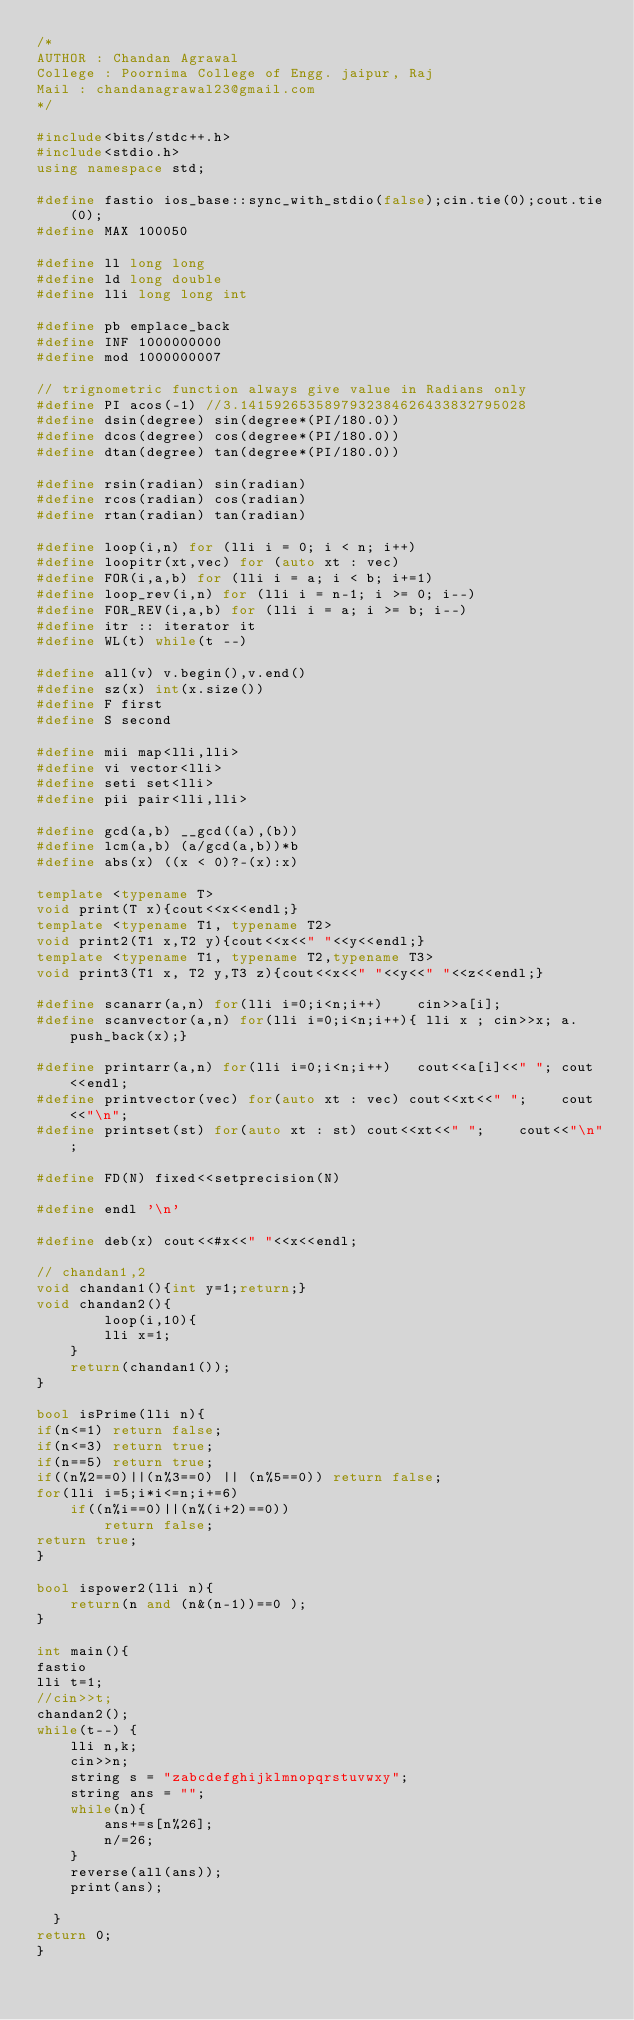Convert code to text. <code><loc_0><loc_0><loc_500><loc_500><_C++_>/*
AUTHOR : Chandan Agrawal
College : Poornima College of Engg. jaipur, Raj
Mail : chandanagrawal23@gmail.com
*/

#include<bits/stdc++.h>
#include<stdio.h>
using namespace std;

#define fastio ios_base::sync_with_stdio(false);cin.tie(0);cout.tie(0);
#define MAX 100050

#define ll long long
#define ld long double
#define lli long long int

#define pb emplace_back
#define INF 1000000000
#define mod 1000000007

// trignometric function always give value in Radians only
#define PI acos(-1) //3.1415926535897932384626433832795028
#define dsin(degree) sin(degree*(PI/180.0))
#define dcos(degree) cos(degree*(PI/180.0))
#define dtan(degree) tan(degree*(PI/180.0))

#define rsin(radian) sin(radian)
#define rcos(radian) cos(radian)
#define rtan(radian) tan(radian)

#define loop(i,n) for (lli i = 0; i < n; i++)
#define loopitr(xt,vec) for (auto xt : vec)
#define FOR(i,a,b) for (lli i = a; i < b; i+=1)
#define loop_rev(i,n) for (lli i = n-1; i >= 0; i--)
#define FOR_REV(i,a,b) for (lli i = a; i >= b; i--)
#define itr :: iterator it
#define WL(t) while(t --)

#define all(v) v.begin(),v.end()
#define sz(x) int(x.size())
#define F first
#define S second

#define mii map<lli,lli>
#define vi vector<lli>
#define seti set<lli>
#define pii pair<lli,lli>

#define gcd(a,b) __gcd((a),(b))
#define lcm(a,b) (a/gcd(a,b))*b
#define abs(x) ((x < 0)?-(x):x)

template <typename T>
void print(T x){cout<<x<<endl;}
template <typename T1, typename T2>
void print2(T1 x,T2 y){cout<<x<<" "<<y<<endl;}
template <typename T1, typename T2,typename T3>
void print3(T1 x, T2 y,T3 z){cout<<x<<" "<<y<<" "<<z<<endl;}

#define scanarr(a,n) for(lli i=0;i<n;i++)    cin>>a[i];
#define scanvector(a,n) for(lli i=0;i<n;i++){ lli x ; cin>>x; a.push_back(x);}

#define printarr(a,n) for(lli i=0;i<n;i++)   cout<<a[i]<<" "; cout<<endl;
#define printvector(vec) for(auto xt : vec) cout<<xt<<" ";    cout<<"\n";
#define printset(st) for(auto xt : st) cout<<xt<<" ";    cout<<"\n";

#define FD(N) fixed<<setprecision(N)

#define endl '\n'

#define deb(x) cout<<#x<<" "<<x<<endl;

// chandan1,2
void chandan1(){int y=1;return;}
void chandan2(){
        loop(i,10){
        lli x=1;
    }
    return(chandan1());
}

bool isPrime(lli n){
if(n<=1) return false;
if(n<=3) return true;
if(n==5) return true;
if((n%2==0)||(n%3==0) || (n%5==0)) return false;
for(lli i=5;i*i<=n;i+=6)
    if((n%i==0)||(n%(i+2)==0))
        return false;
return true;
}

bool ispower2(lli n){
    return(n and (n&(n-1))==0 );
}

int main(){
fastio
lli t=1;
//cin>>t;
chandan2();
while(t--) {
    lli n,k;
    cin>>n;
    string s = "zabcdefghijklmnopqrstuvwxy";
    string ans = "";
    while(n){
        ans+=s[n%26];
        n/=26;
    }
    reverse(all(ans));
    print(ans);
    
  } 
return 0;
}</code> 